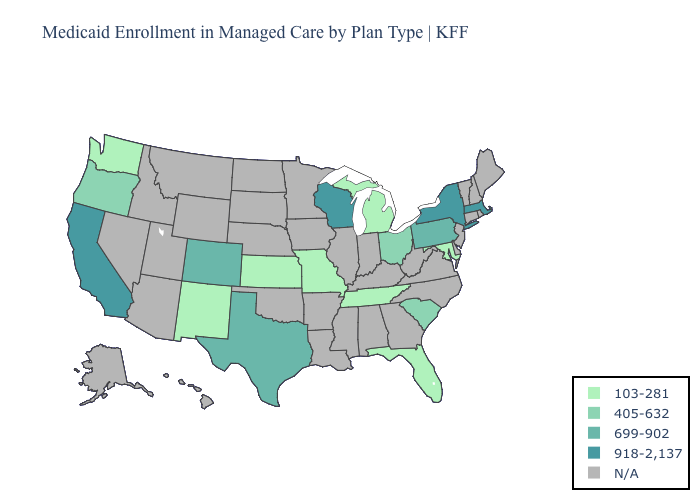Is the legend a continuous bar?
Concise answer only. No. Which states hav the highest value in the MidWest?
Keep it brief. Wisconsin. Name the states that have a value in the range 918-2,137?
Quick response, please. California, Massachusetts, New York, Wisconsin. Among the states that border Indiana , does Ohio have the lowest value?
Concise answer only. No. Name the states that have a value in the range 405-632?
Quick response, please. Ohio, Oregon, South Carolina. What is the value of Florida?
Keep it brief. 103-281. Name the states that have a value in the range 699-902?
Write a very short answer. Colorado, Pennsylvania, Texas. Which states have the lowest value in the USA?
Concise answer only. Florida, Kansas, Maryland, Michigan, Missouri, New Mexico, Tennessee, Washington. What is the highest value in states that border New Hampshire?
Quick response, please. 918-2,137. What is the highest value in the USA?
Short answer required. 918-2,137. What is the value of Montana?
Write a very short answer. N/A. What is the value of Maryland?
Give a very brief answer. 103-281. What is the highest value in the USA?
Quick response, please. 918-2,137. What is the value of Georgia?
Keep it brief. N/A. Among the states that border Missouri , which have the highest value?
Be succinct. Kansas, Tennessee. 